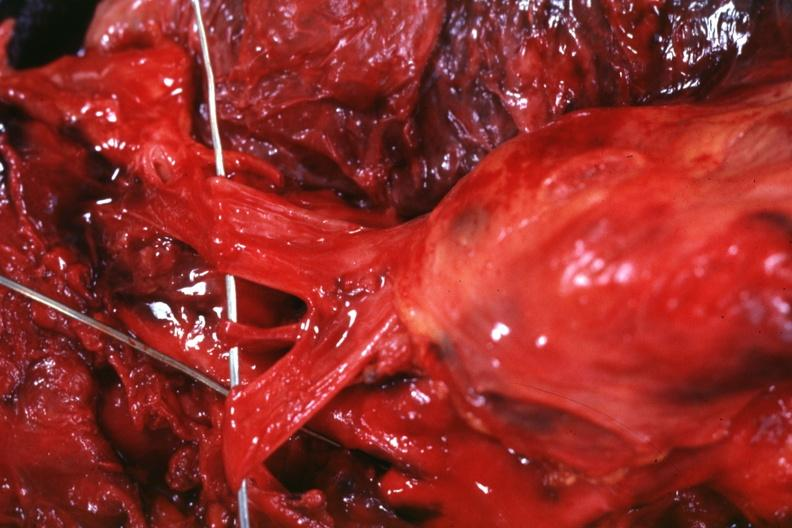what is invaded by the tumor?
Answer the question using a single word or phrase. The superior vena cava 